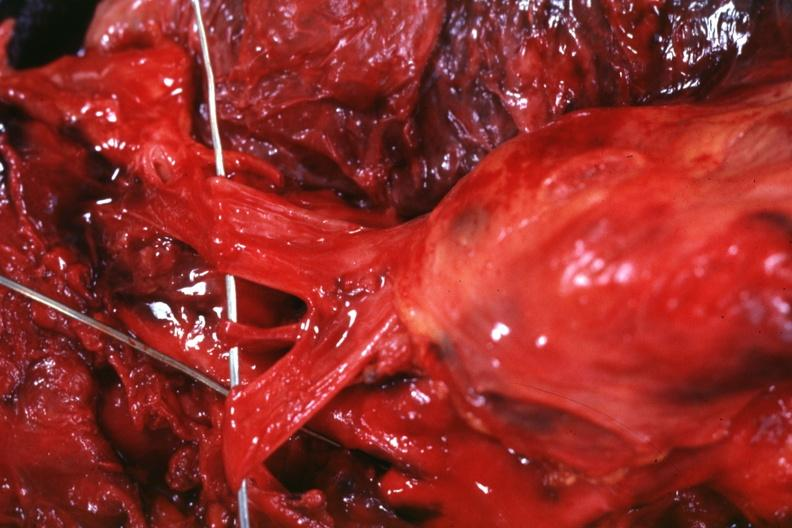what is invaded by the tumor?
Answer the question using a single word or phrase. The superior vena cava 